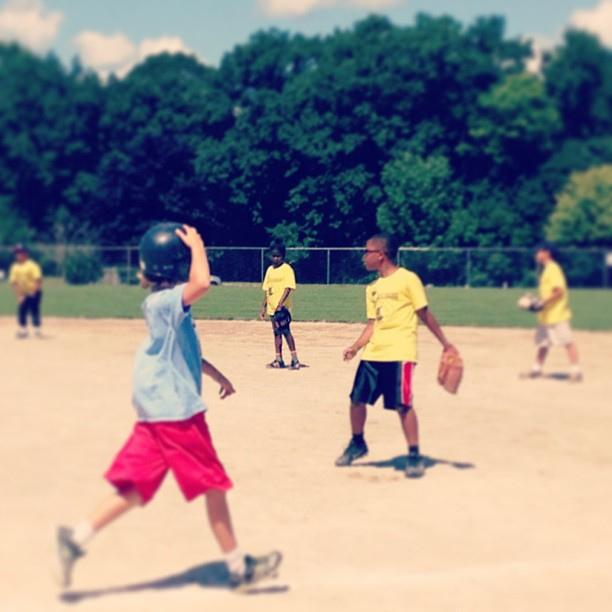What color are the shorts on the boy wearing a baseball helmet? Please explain your reasoning. red. The color is like a darkish pink color that's similar to magenta. 